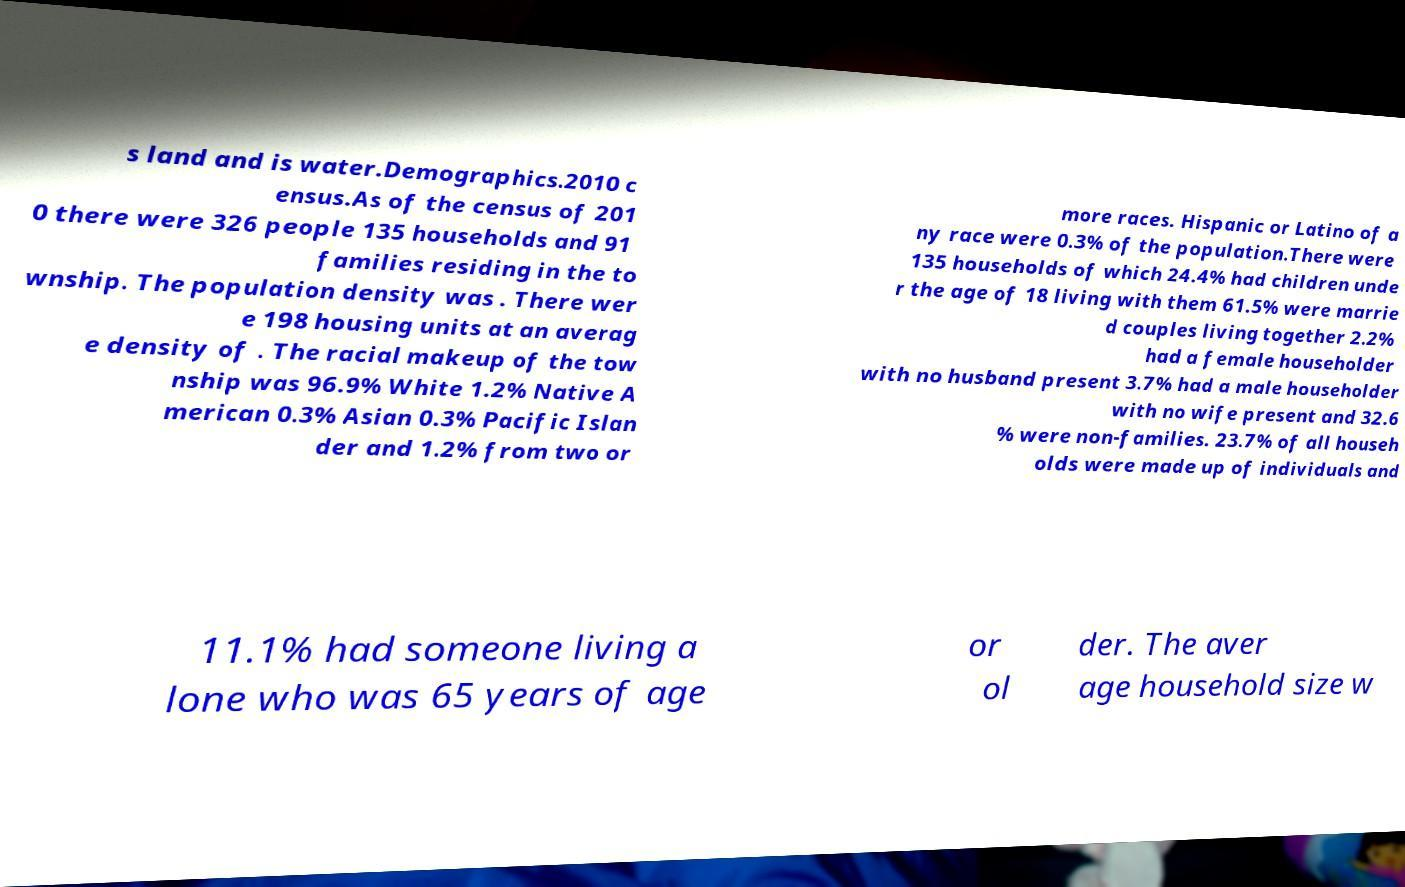What messages or text are displayed in this image? I need them in a readable, typed format. s land and is water.Demographics.2010 c ensus.As of the census of 201 0 there were 326 people 135 households and 91 families residing in the to wnship. The population density was . There wer e 198 housing units at an averag e density of . The racial makeup of the tow nship was 96.9% White 1.2% Native A merican 0.3% Asian 0.3% Pacific Islan der and 1.2% from two or more races. Hispanic or Latino of a ny race were 0.3% of the population.There were 135 households of which 24.4% had children unde r the age of 18 living with them 61.5% were marrie d couples living together 2.2% had a female householder with no husband present 3.7% had a male householder with no wife present and 32.6 % were non-families. 23.7% of all househ olds were made up of individuals and 11.1% had someone living a lone who was 65 years of age or ol der. The aver age household size w 